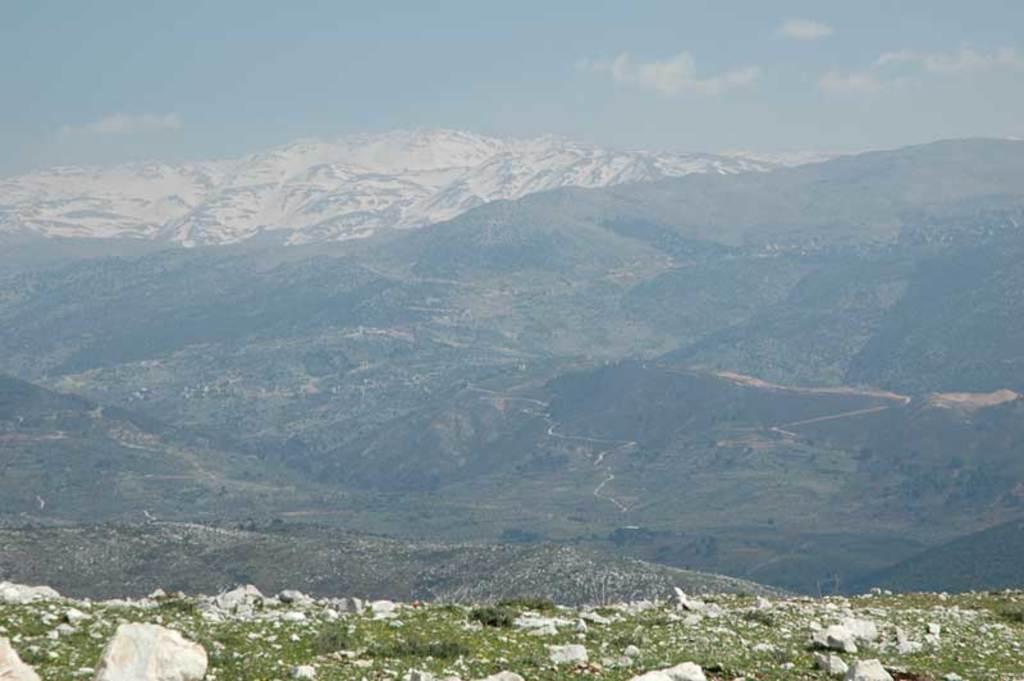In one or two sentences, can you explain what this image depicts? In this image we can see the mountains, some rocks, some snow on the surface, some trees, bushes, plants and grass on the surface. At the top there is the sky. 